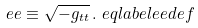<formula> <loc_0><loc_0><loc_500><loc_500>\ e e \equiv \sqrt { - g _ { t t } } \, . \ e q l a b e l { e e d e f }</formula> 